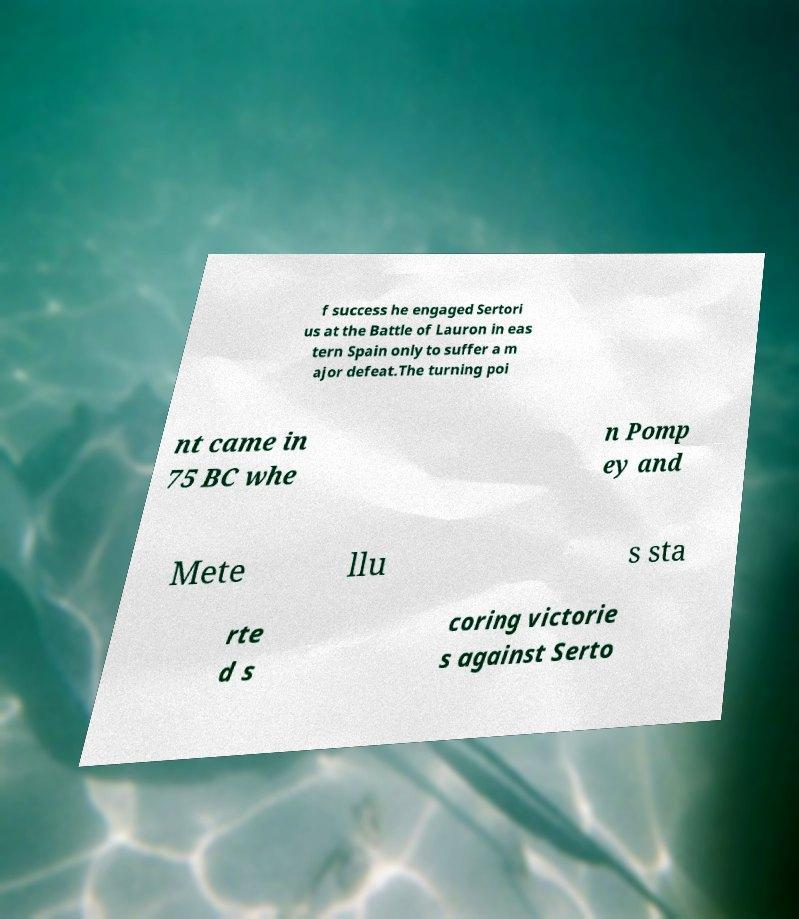What messages or text are displayed in this image? I need them in a readable, typed format. f success he engaged Sertori us at the Battle of Lauron in eas tern Spain only to suffer a m ajor defeat.The turning poi nt came in 75 BC whe n Pomp ey and Mete llu s sta rte d s coring victorie s against Serto 